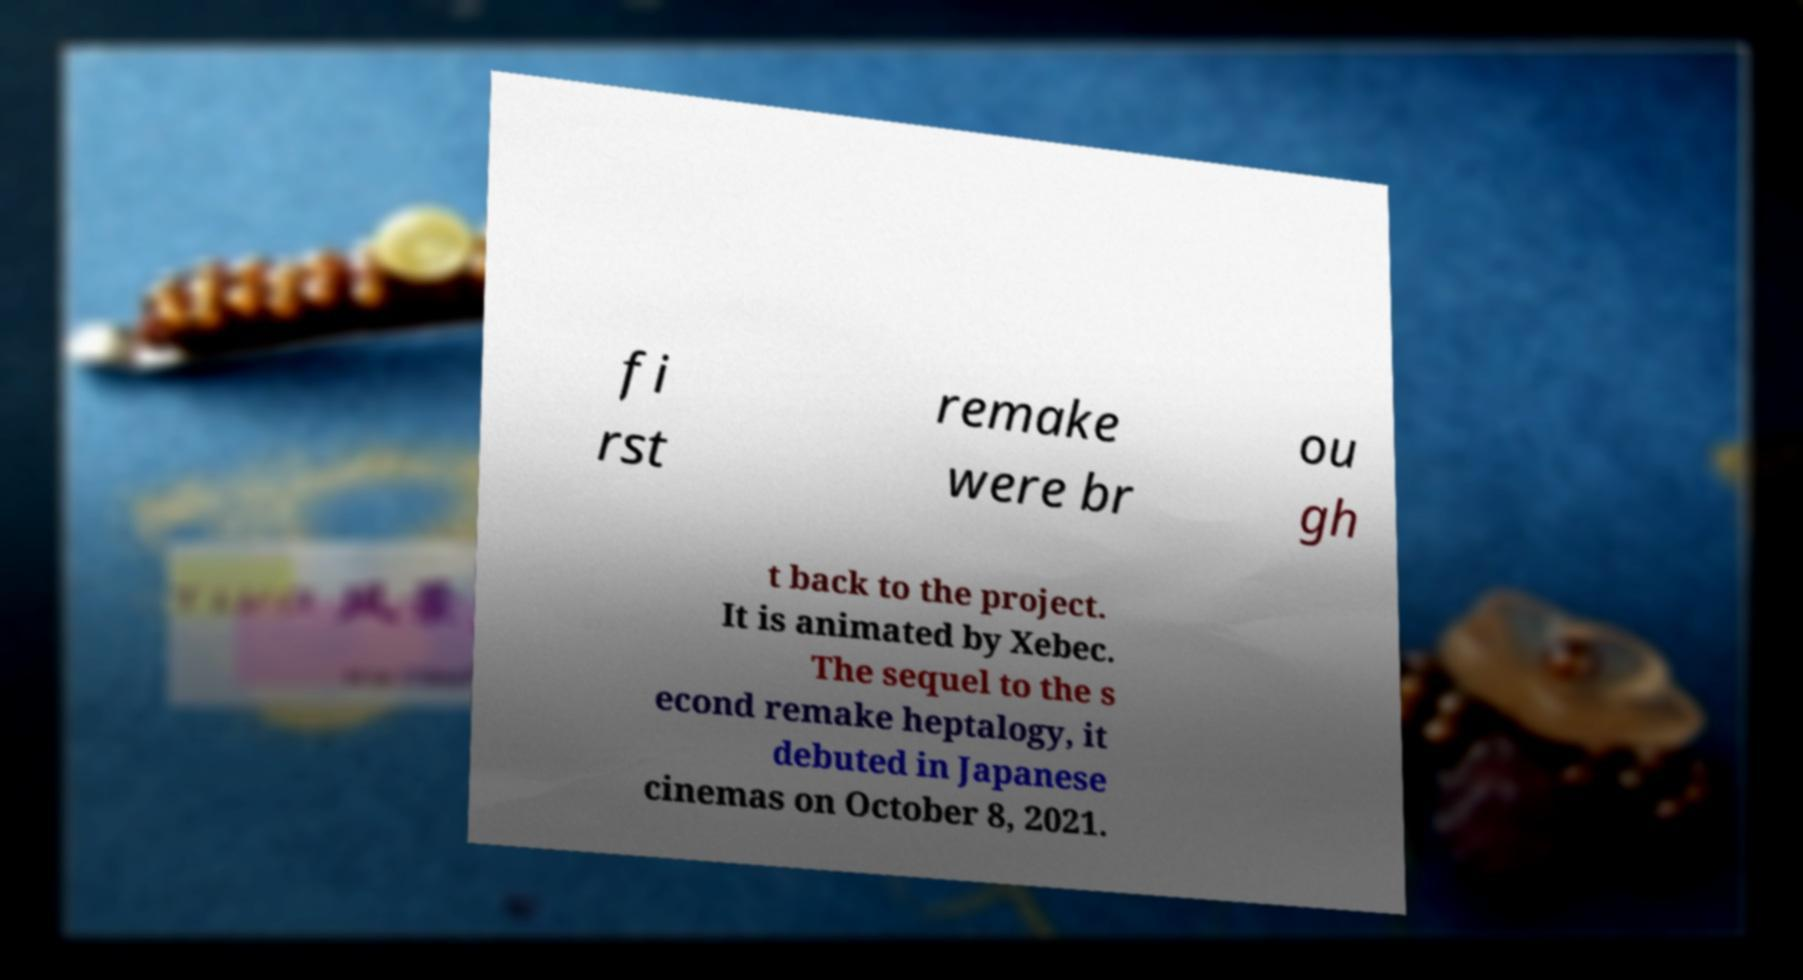Please identify and transcribe the text found in this image. fi rst remake were br ou gh t back to the project. It is animated by Xebec. The sequel to the s econd remake heptalogy, it debuted in Japanese cinemas on October 8, 2021. 